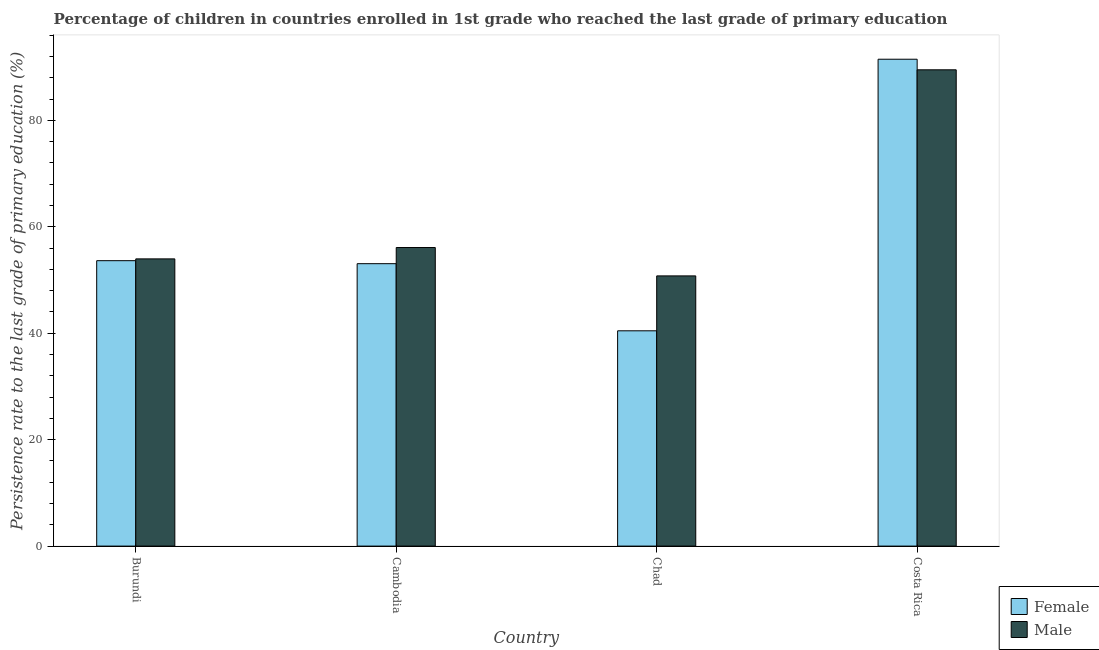What is the label of the 3rd group of bars from the left?
Provide a succinct answer. Chad. What is the persistence rate of female students in Costa Rica?
Your response must be concise. 91.5. Across all countries, what is the maximum persistence rate of male students?
Provide a succinct answer. 89.52. Across all countries, what is the minimum persistence rate of male students?
Provide a succinct answer. 50.78. In which country was the persistence rate of female students minimum?
Your response must be concise. Chad. What is the total persistence rate of female students in the graph?
Keep it short and to the point. 238.69. What is the difference between the persistence rate of male students in Chad and that in Costa Rica?
Ensure brevity in your answer.  -38.73. What is the difference between the persistence rate of male students in Chad and the persistence rate of female students in Costa Rica?
Your answer should be very brief. -40.72. What is the average persistence rate of male students per country?
Give a very brief answer. 62.6. What is the difference between the persistence rate of female students and persistence rate of male students in Cambodia?
Give a very brief answer. -3.04. What is the ratio of the persistence rate of female students in Chad to that in Costa Rica?
Give a very brief answer. 0.44. What is the difference between the highest and the second highest persistence rate of male students?
Your response must be concise. 33.4. What is the difference between the highest and the lowest persistence rate of male students?
Offer a terse response. 38.73. Are all the bars in the graph horizontal?
Your answer should be very brief. No. Does the graph contain any zero values?
Offer a terse response. No. Where does the legend appear in the graph?
Offer a very short reply. Bottom right. How are the legend labels stacked?
Offer a terse response. Vertical. What is the title of the graph?
Ensure brevity in your answer.  Percentage of children in countries enrolled in 1st grade who reached the last grade of primary education. Does "Grants" appear as one of the legend labels in the graph?
Keep it short and to the point. No. What is the label or title of the X-axis?
Provide a short and direct response. Country. What is the label or title of the Y-axis?
Make the answer very short. Persistence rate to the last grade of primary education (%). What is the Persistence rate to the last grade of primary education (%) of Female in Burundi?
Your answer should be very brief. 53.64. What is the Persistence rate to the last grade of primary education (%) of Male in Burundi?
Your answer should be very brief. 53.98. What is the Persistence rate to the last grade of primary education (%) of Female in Cambodia?
Provide a succinct answer. 53.08. What is the Persistence rate to the last grade of primary education (%) in Male in Cambodia?
Provide a short and direct response. 56.11. What is the Persistence rate to the last grade of primary education (%) of Female in Chad?
Make the answer very short. 40.46. What is the Persistence rate to the last grade of primary education (%) in Male in Chad?
Give a very brief answer. 50.78. What is the Persistence rate to the last grade of primary education (%) in Female in Costa Rica?
Provide a short and direct response. 91.5. What is the Persistence rate to the last grade of primary education (%) of Male in Costa Rica?
Your answer should be very brief. 89.52. Across all countries, what is the maximum Persistence rate to the last grade of primary education (%) of Female?
Make the answer very short. 91.5. Across all countries, what is the maximum Persistence rate to the last grade of primary education (%) of Male?
Your response must be concise. 89.52. Across all countries, what is the minimum Persistence rate to the last grade of primary education (%) of Female?
Offer a terse response. 40.46. Across all countries, what is the minimum Persistence rate to the last grade of primary education (%) in Male?
Provide a short and direct response. 50.78. What is the total Persistence rate to the last grade of primary education (%) of Female in the graph?
Ensure brevity in your answer.  238.69. What is the total Persistence rate to the last grade of primary education (%) in Male in the graph?
Offer a terse response. 250.39. What is the difference between the Persistence rate to the last grade of primary education (%) of Female in Burundi and that in Cambodia?
Keep it short and to the point. 0.56. What is the difference between the Persistence rate to the last grade of primary education (%) of Male in Burundi and that in Cambodia?
Make the answer very short. -2.13. What is the difference between the Persistence rate to the last grade of primary education (%) of Female in Burundi and that in Chad?
Your response must be concise. 13.18. What is the difference between the Persistence rate to the last grade of primary education (%) of Male in Burundi and that in Chad?
Your answer should be very brief. 3.2. What is the difference between the Persistence rate to the last grade of primary education (%) in Female in Burundi and that in Costa Rica?
Your answer should be very brief. -37.86. What is the difference between the Persistence rate to the last grade of primary education (%) in Male in Burundi and that in Costa Rica?
Ensure brevity in your answer.  -35.54. What is the difference between the Persistence rate to the last grade of primary education (%) in Female in Cambodia and that in Chad?
Your answer should be compact. 12.62. What is the difference between the Persistence rate to the last grade of primary education (%) in Male in Cambodia and that in Chad?
Your response must be concise. 5.33. What is the difference between the Persistence rate to the last grade of primary education (%) of Female in Cambodia and that in Costa Rica?
Keep it short and to the point. -38.43. What is the difference between the Persistence rate to the last grade of primary education (%) of Male in Cambodia and that in Costa Rica?
Provide a short and direct response. -33.4. What is the difference between the Persistence rate to the last grade of primary education (%) of Female in Chad and that in Costa Rica?
Make the answer very short. -51.04. What is the difference between the Persistence rate to the last grade of primary education (%) in Male in Chad and that in Costa Rica?
Your response must be concise. -38.73. What is the difference between the Persistence rate to the last grade of primary education (%) of Female in Burundi and the Persistence rate to the last grade of primary education (%) of Male in Cambodia?
Offer a terse response. -2.47. What is the difference between the Persistence rate to the last grade of primary education (%) in Female in Burundi and the Persistence rate to the last grade of primary education (%) in Male in Chad?
Keep it short and to the point. 2.86. What is the difference between the Persistence rate to the last grade of primary education (%) in Female in Burundi and the Persistence rate to the last grade of primary education (%) in Male in Costa Rica?
Give a very brief answer. -35.87. What is the difference between the Persistence rate to the last grade of primary education (%) in Female in Cambodia and the Persistence rate to the last grade of primary education (%) in Male in Chad?
Provide a succinct answer. 2.3. What is the difference between the Persistence rate to the last grade of primary education (%) in Female in Cambodia and the Persistence rate to the last grade of primary education (%) in Male in Costa Rica?
Ensure brevity in your answer.  -36.44. What is the difference between the Persistence rate to the last grade of primary education (%) in Female in Chad and the Persistence rate to the last grade of primary education (%) in Male in Costa Rica?
Provide a succinct answer. -49.05. What is the average Persistence rate to the last grade of primary education (%) in Female per country?
Your answer should be compact. 59.67. What is the average Persistence rate to the last grade of primary education (%) in Male per country?
Your answer should be very brief. 62.6. What is the difference between the Persistence rate to the last grade of primary education (%) of Female and Persistence rate to the last grade of primary education (%) of Male in Burundi?
Keep it short and to the point. -0.34. What is the difference between the Persistence rate to the last grade of primary education (%) in Female and Persistence rate to the last grade of primary education (%) in Male in Cambodia?
Offer a terse response. -3.04. What is the difference between the Persistence rate to the last grade of primary education (%) in Female and Persistence rate to the last grade of primary education (%) in Male in Chad?
Your response must be concise. -10.32. What is the difference between the Persistence rate to the last grade of primary education (%) in Female and Persistence rate to the last grade of primary education (%) in Male in Costa Rica?
Offer a terse response. 1.99. What is the ratio of the Persistence rate to the last grade of primary education (%) in Female in Burundi to that in Cambodia?
Your answer should be very brief. 1.01. What is the ratio of the Persistence rate to the last grade of primary education (%) in Male in Burundi to that in Cambodia?
Ensure brevity in your answer.  0.96. What is the ratio of the Persistence rate to the last grade of primary education (%) in Female in Burundi to that in Chad?
Provide a succinct answer. 1.33. What is the ratio of the Persistence rate to the last grade of primary education (%) of Male in Burundi to that in Chad?
Offer a terse response. 1.06. What is the ratio of the Persistence rate to the last grade of primary education (%) in Female in Burundi to that in Costa Rica?
Ensure brevity in your answer.  0.59. What is the ratio of the Persistence rate to the last grade of primary education (%) in Male in Burundi to that in Costa Rica?
Your response must be concise. 0.6. What is the ratio of the Persistence rate to the last grade of primary education (%) of Female in Cambodia to that in Chad?
Offer a terse response. 1.31. What is the ratio of the Persistence rate to the last grade of primary education (%) of Male in Cambodia to that in Chad?
Your response must be concise. 1.1. What is the ratio of the Persistence rate to the last grade of primary education (%) in Female in Cambodia to that in Costa Rica?
Offer a terse response. 0.58. What is the ratio of the Persistence rate to the last grade of primary education (%) of Male in Cambodia to that in Costa Rica?
Make the answer very short. 0.63. What is the ratio of the Persistence rate to the last grade of primary education (%) of Female in Chad to that in Costa Rica?
Provide a short and direct response. 0.44. What is the ratio of the Persistence rate to the last grade of primary education (%) in Male in Chad to that in Costa Rica?
Your answer should be very brief. 0.57. What is the difference between the highest and the second highest Persistence rate to the last grade of primary education (%) of Female?
Your answer should be compact. 37.86. What is the difference between the highest and the second highest Persistence rate to the last grade of primary education (%) in Male?
Provide a succinct answer. 33.4. What is the difference between the highest and the lowest Persistence rate to the last grade of primary education (%) of Female?
Your answer should be very brief. 51.04. What is the difference between the highest and the lowest Persistence rate to the last grade of primary education (%) in Male?
Your answer should be very brief. 38.73. 